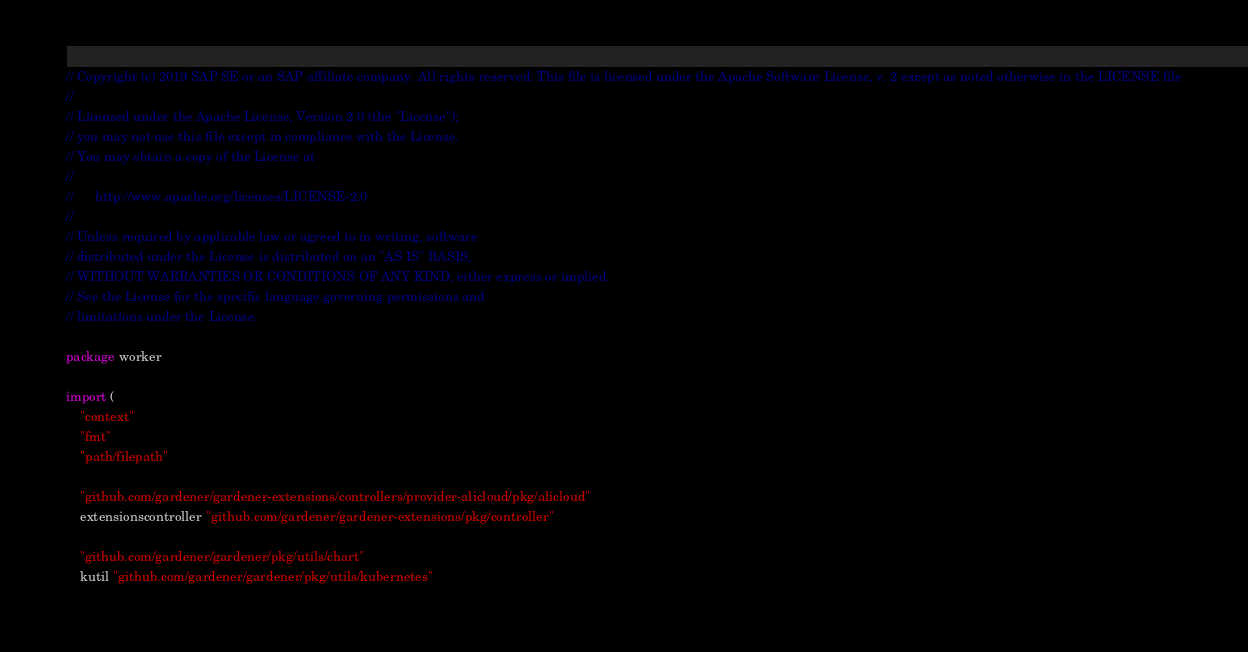<code> <loc_0><loc_0><loc_500><loc_500><_Go_>// Copyright (c) 2019 SAP SE or an SAP affiliate company. All rights reserved. This file is licensed under the Apache Software License, v. 2 except as noted otherwise in the LICENSE file
//
// Licensed under the Apache License, Version 2.0 (the "License");
// you may not use this file except in compliance with the License.
// You may obtain a copy of the License at
//
//      http://www.apache.org/licenses/LICENSE-2.0
//
// Unless required by applicable law or agreed to in writing, software
// distributed under the License is distributed on an "AS IS" BASIS,
// WITHOUT WARRANTIES OR CONDITIONS OF ANY KIND, either express or implied.
// See the License for the specific language governing permissions and
// limitations under the License.

package worker

import (
	"context"
	"fmt"
	"path/filepath"

	"github.com/gardener/gardener-extensions/controllers/provider-alicloud/pkg/alicloud"
	extensionscontroller "github.com/gardener/gardener-extensions/pkg/controller"

	"github.com/gardener/gardener/pkg/utils/chart"
	kutil "github.com/gardener/gardener/pkg/utils/kubernetes"</code> 